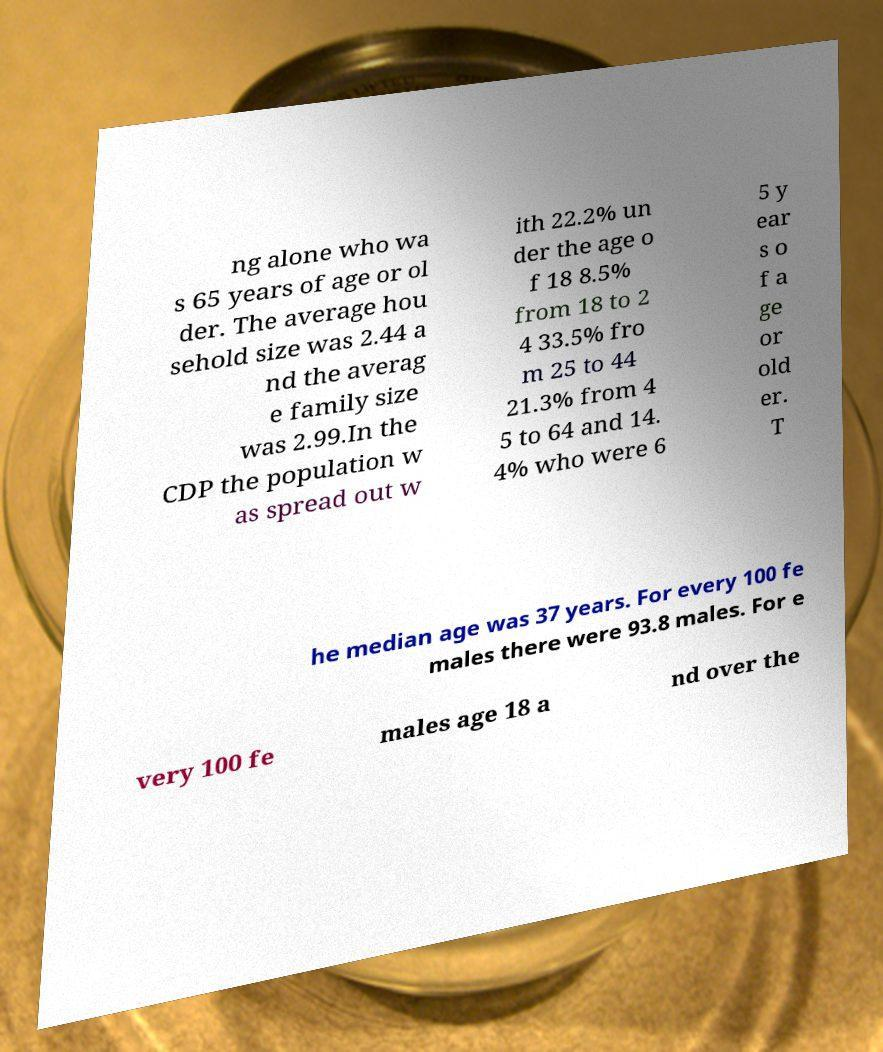Could you extract and type out the text from this image? ng alone who wa s 65 years of age or ol der. The average hou sehold size was 2.44 a nd the averag e family size was 2.99.In the CDP the population w as spread out w ith 22.2% un der the age o f 18 8.5% from 18 to 2 4 33.5% fro m 25 to 44 21.3% from 4 5 to 64 and 14. 4% who were 6 5 y ear s o f a ge or old er. T he median age was 37 years. For every 100 fe males there were 93.8 males. For e very 100 fe males age 18 a nd over the 